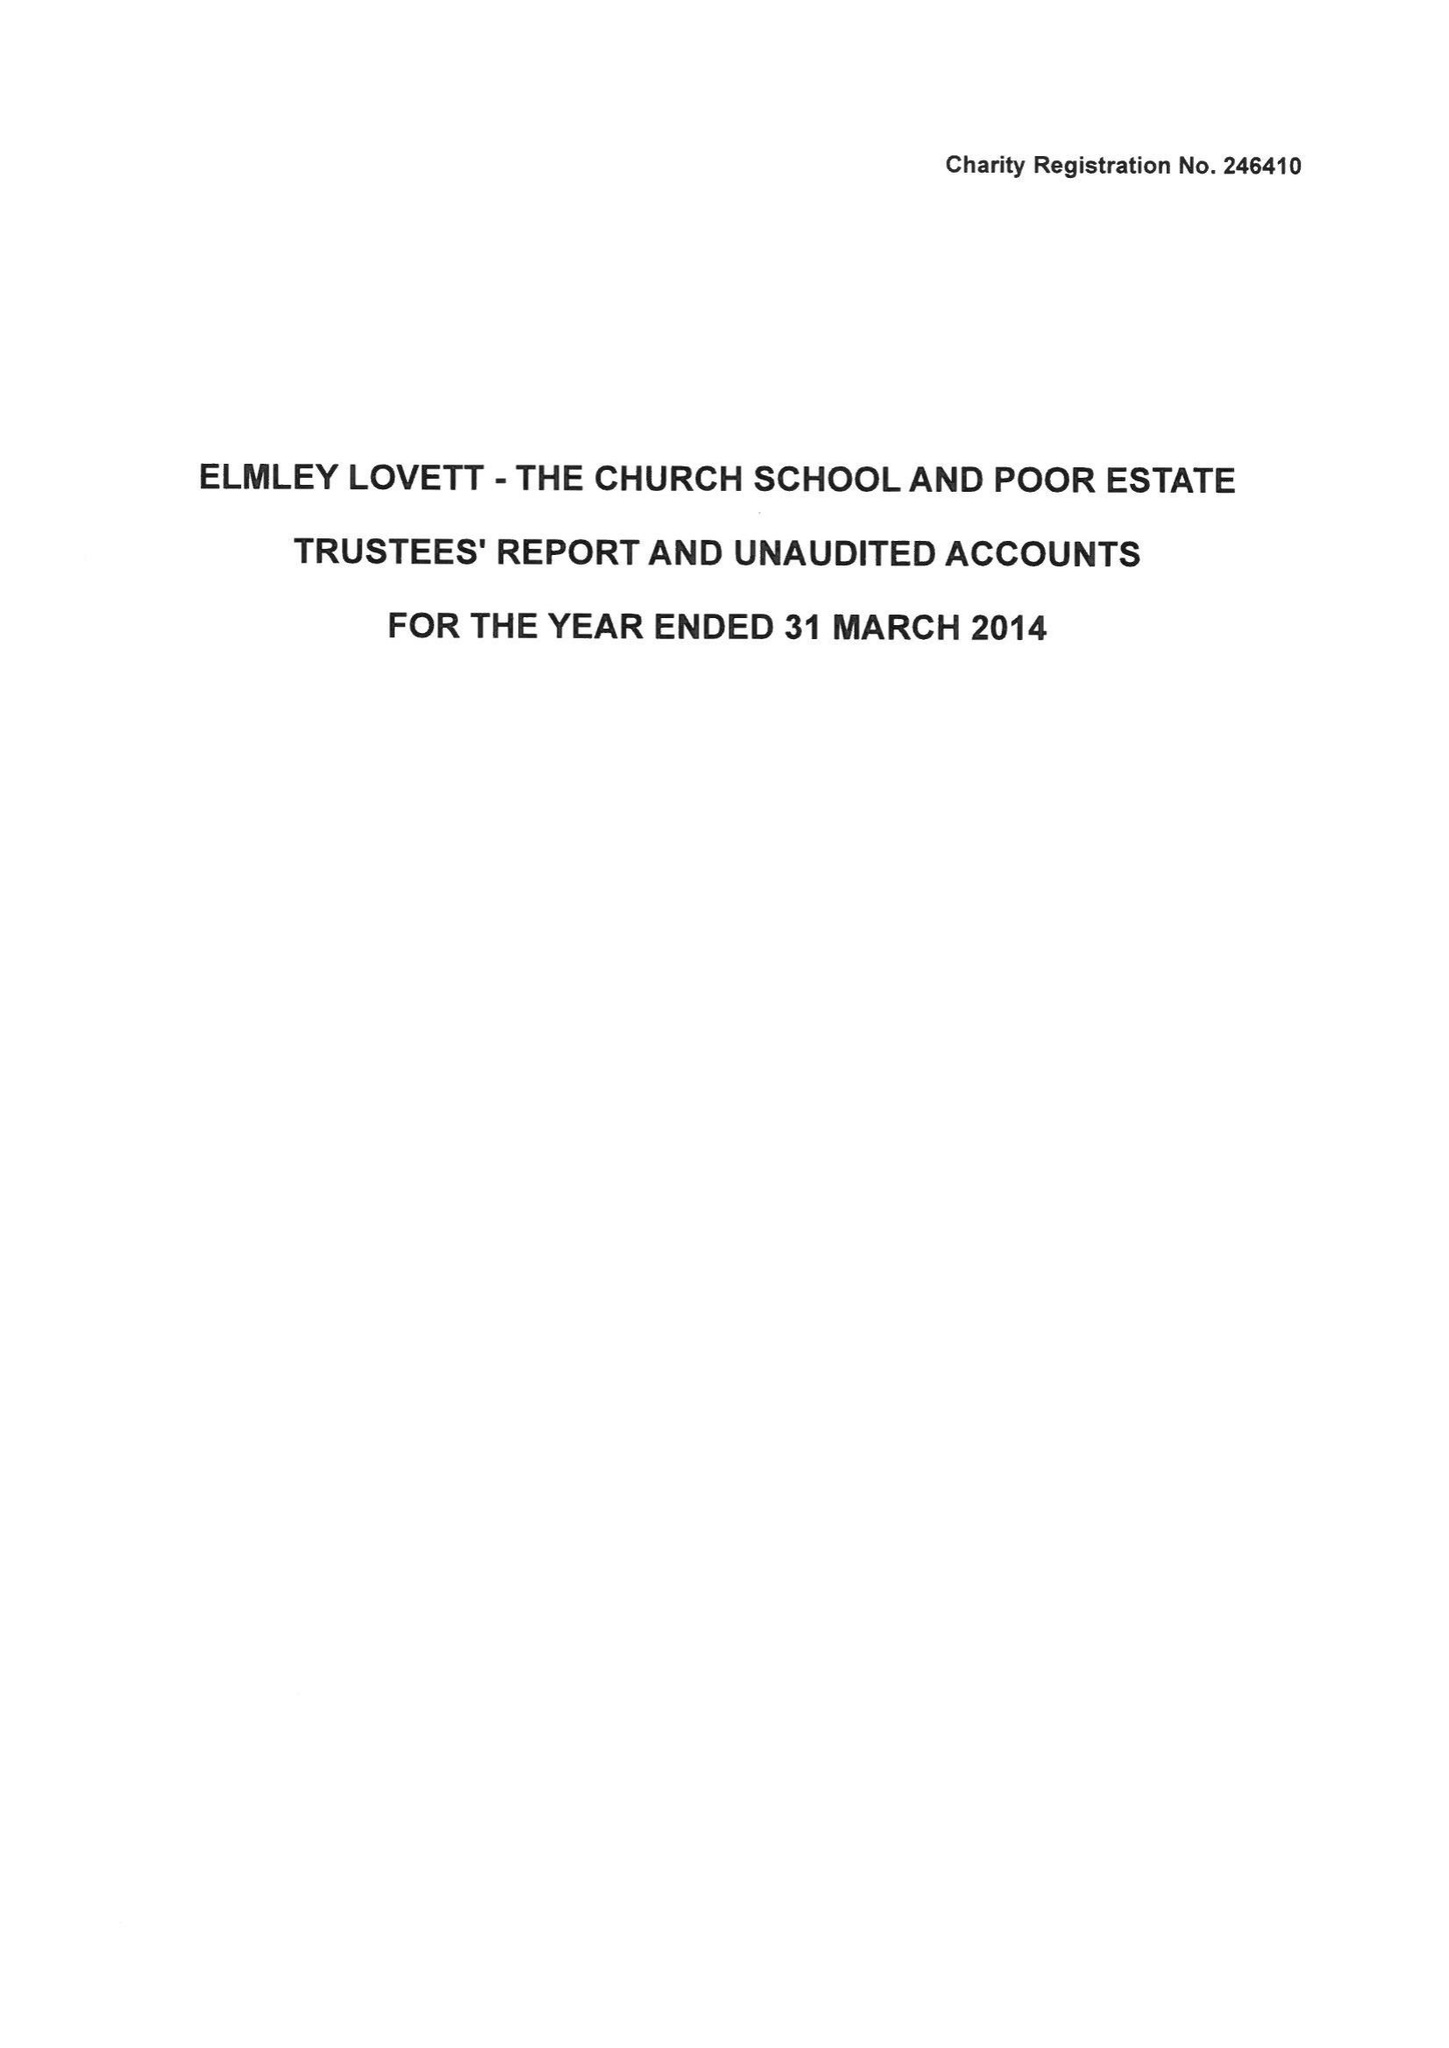What is the value for the charity_number?
Answer the question using a single word or phrase. 246410 